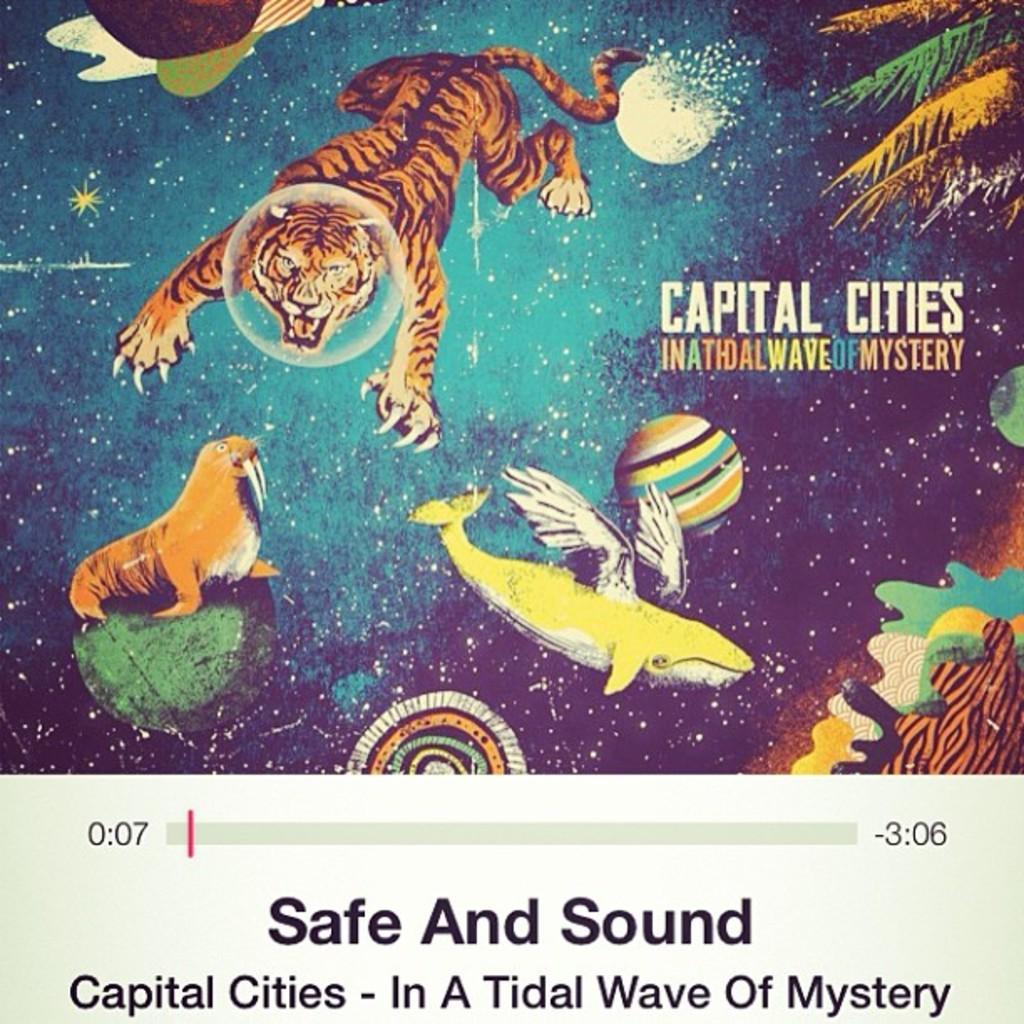How would you summarize this image in a sentence or two? This is a magazine and here we can see some text and there are some pictures of animals and trees. 